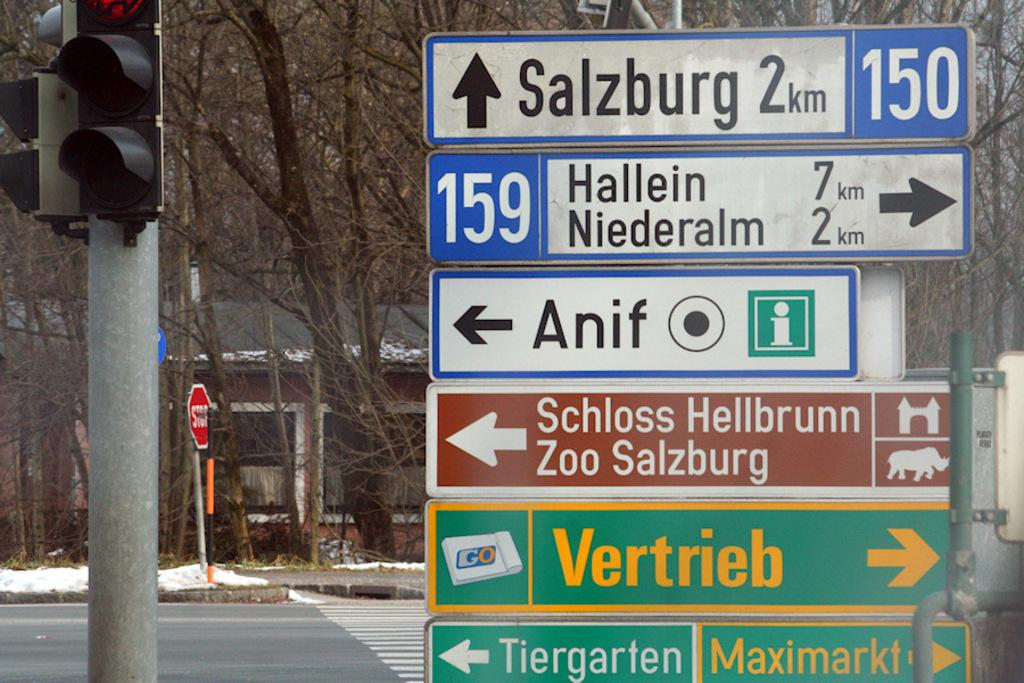Provide a one-sentence caption for the provided image. A points to Salzburg with 2 km ahead. 